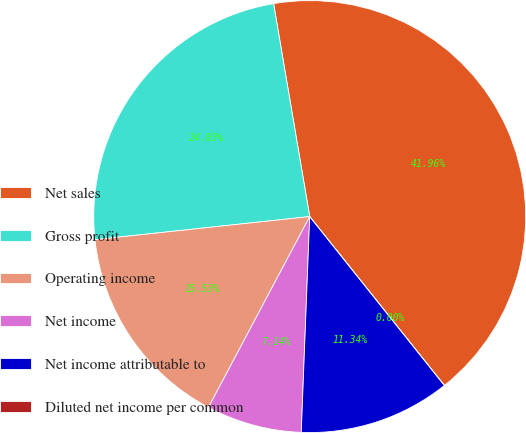<chart> <loc_0><loc_0><loc_500><loc_500><pie_chart><fcel>Net sales<fcel>Gross profit<fcel>Operating income<fcel>Net income<fcel>Net income attributable to<fcel>Diluted net income per common<nl><fcel>41.96%<fcel>24.03%<fcel>15.53%<fcel>7.14%<fcel>11.34%<fcel>0.0%<nl></chart> 